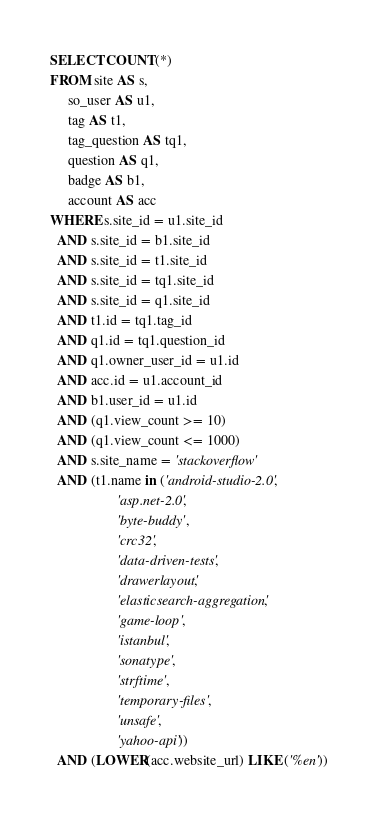<code> <loc_0><loc_0><loc_500><loc_500><_SQL_>SELECT COUNT(*)
FROM site AS s,
     so_user AS u1,
     tag AS t1,
     tag_question AS tq1,
     question AS q1,
     badge AS b1,
     account AS acc
WHERE s.site_id = u1.site_id
  AND s.site_id = b1.site_id
  AND s.site_id = t1.site_id
  AND s.site_id = tq1.site_id
  AND s.site_id = q1.site_id
  AND t1.id = tq1.tag_id
  AND q1.id = tq1.question_id
  AND q1.owner_user_id = u1.id
  AND acc.id = u1.account_id
  AND b1.user_id = u1.id
  AND (q1.view_count >= 10)
  AND (q1.view_count <= 1000)
  AND s.site_name = 'stackoverflow'
  AND (t1.name in ('android-studio-2.0',
                   'asp.net-2.0',
                   'byte-buddy',
                   'crc32',
                   'data-driven-tests',
                   'drawerlayout',
                   'elasticsearch-aggregation',
                   'game-loop',
                   'istanbul',
                   'sonatype',
                   'strftime',
                   'temporary-files',
                   'unsafe',
                   'yahoo-api'))
  AND (LOWER(acc.website_url) LIKE ('%en'))</code> 